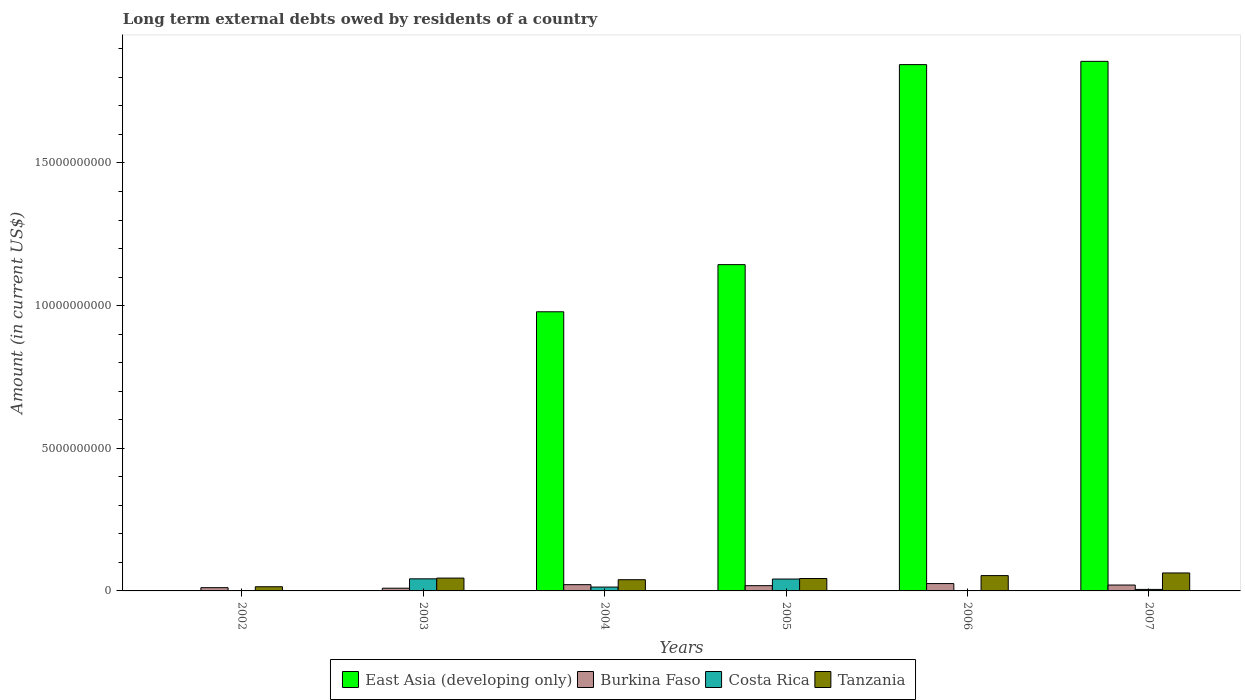How many different coloured bars are there?
Your response must be concise. 4. Are the number of bars per tick equal to the number of legend labels?
Your response must be concise. No. What is the label of the 2nd group of bars from the left?
Your answer should be compact. 2003. What is the amount of long-term external debts owed by residents in Tanzania in 2003?
Offer a very short reply. 4.50e+08. Across all years, what is the maximum amount of long-term external debts owed by residents in Tanzania?
Ensure brevity in your answer.  6.30e+08. Across all years, what is the minimum amount of long-term external debts owed by residents in East Asia (developing only)?
Your response must be concise. 0. In which year was the amount of long-term external debts owed by residents in Tanzania maximum?
Give a very brief answer. 2007. What is the total amount of long-term external debts owed by residents in East Asia (developing only) in the graph?
Offer a terse response. 5.82e+1. What is the difference between the amount of long-term external debts owed by residents in East Asia (developing only) in 2004 and that in 2007?
Provide a succinct answer. -8.78e+09. What is the difference between the amount of long-term external debts owed by residents in Burkina Faso in 2007 and the amount of long-term external debts owed by residents in Costa Rica in 2004?
Your answer should be compact. 7.13e+07. What is the average amount of long-term external debts owed by residents in East Asia (developing only) per year?
Give a very brief answer. 9.71e+09. In the year 2004, what is the difference between the amount of long-term external debts owed by residents in Tanzania and amount of long-term external debts owed by residents in Burkina Faso?
Give a very brief answer. 1.74e+08. What is the ratio of the amount of long-term external debts owed by residents in East Asia (developing only) in 2005 to that in 2007?
Your answer should be very brief. 0.62. Is the amount of long-term external debts owed by residents in Tanzania in 2003 less than that in 2006?
Provide a short and direct response. Yes. What is the difference between the highest and the second highest amount of long-term external debts owed by residents in Burkina Faso?
Give a very brief answer. 3.86e+07. What is the difference between the highest and the lowest amount of long-term external debts owed by residents in Burkina Faso?
Give a very brief answer. 1.62e+08. Is the sum of the amount of long-term external debts owed by residents in Burkina Faso in 2002 and 2004 greater than the maximum amount of long-term external debts owed by residents in Costa Rica across all years?
Provide a succinct answer. No. How many years are there in the graph?
Provide a short and direct response. 6. What is the difference between two consecutive major ticks on the Y-axis?
Your answer should be very brief. 5.00e+09. Are the values on the major ticks of Y-axis written in scientific E-notation?
Ensure brevity in your answer.  No. Does the graph contain any zero values?
Provide a short and direct response. Yes. What is the title of the graph?
Your response must be concise. Long term external debts owed by residents of a country. Does "Peru" appear as one of the legend labels in the graph?
Provide a succinct answer. No. What is the Amount (in current US$) of East Asia (developing only) in 2002?
Your answer should be very brief. 0. What is the Amount (in current US$) of Burkina Faso in 2002?
Give a very brief answer. 1.14e+08. What is the Amount (in current US$) in Costa Rica in 2002?
Provide a short and direct response. 0. What is the Amount (in current US$) of Tanzania in 2002?
Make the answer very short. 1.46e+08. What is the Amount (in current US$) in Burkina Faso in 2003?
Give a very brief answer. 9.52e+07. What is the Amount (in current US$) in Costa Rica in 2003?
Your answer should be compact. 4.24e+08. What is the Amount (in current US$) in Tanzania in 2003?
Offer a very short reply. 4.50e+08. What is the Amount (in current US$) of East Asia (developing only) in 2004?
Your response must be concise. 9.78e+09. What is the Amount (in current US$) of Burkina Faso in 2004?
Make the answer very short. 2.19e+08. What is the Amount (in current US$) in Costa Rica in 2004?
Your answer should be compact. 1.35e+08. What is the Amount (in current US$) in Tanzania in 2004?
Make the answer very short. 3.93e+08. What is the Amount (in current US$) in East Asia (developing only) in 2005?
Provide a short and direct response. 1.14e+1. What is the Amount (in current US$) of Burkina Faso in 2005?
Keep it short and to the point. 1.84e+08. What is the Amount (in current US$) in Costa Rica in 2005?
Give a very brief answer. 4.17e+08. What is the Amount (in current US$) of Tanzania in 2005?
Your answer should be compact. 4.35e+08. What is the Amount (in current US$) in East Asia (developing only) in 2006?
Keep it short and to the point. 1.84e+1. What is the Amount (in current US$) in Burkina Faso in 2006?
Make the answer very short. 2.58e+08. What is the Amount (in current US$) in Tanzania in 2006?
Make the answer very short. 5.37e+08. What is the Amount (in current US$) in East Asia (developing only) in 2007?
Ensure brevity in your answer.  1.86e+1. What is the Amount (in current US$) in Burkina Faso in 2007?
Keep it short and to the point. 2.06e+08. What is the Amount (in current US$) of Costa Rica in 2007?
Make the answer very short. 5.27e+07. What is the Amount (in current US$) in Tanzania in 2007?
Your answer should be compact. 6.30e+08. Across all years, what is the maximum Amount (in current US$) in East Asia (developing only)?
Your answer should be very brief. 1.86e+1. Across all years, what is the maximum Amount (in current US$) in Burkina Faso?
Ensure brevity in your answer.  2.58e+08. Across all years, what is the maximum Amount (in current US$) in Costa Rica?
Your answer should be very brief. 4.24e+08. Across all years, what is the maximum Amount (in current US$) in Tanzania?
Make the answer very short. 6.30e+08. Across all years, what is the minimum Amount (in current US$) in East Asia (developing only)?
Provide a short and direct response. 0. Across all years, what is the minimum Amount (in current US$) in Burkina Faso?
Keep it short and to the point. 9.52e+07. Across all years, what is the minimum Amount (in current US$) of Costa Rica?
Give a very brief answer. 0. Across all years, what is the minimum Amount (in current US$) in Tanzania?
Offer a very short reply. 1.46e+08. What is the total Amount (in current US$) of East Asia (developing only) in the graph?
Your response must be concise. 5.82e+1. What is the total Amount (in current US$) in Burkina Faso in the graph?
Your answer should be very brief. 1.08e+09. What is the total Amount (in current US$) of Costa Rica in the graph?
Your response must be concise. 1.03e+09. What is the total Amount (in current US$) in Tanzania in the graph?
Offer a terse response. 2.59e+09. What is the difference between the Amount (in current US$) in Burkina Faso in 2002 and that in 2003?
Your answer should be very brief. 1.88e+07. What is the difference between the Amount (in current US$) of Tanzania in 2002 and that in 2003?
Your answer should be very brief. -3.04e+08. What is the difference between the Amount (in current US$) in Burkina Faso in 2002 and that in 2004?
Your answer should be compact. -1.05e+08. What is the difference between the Amount (in current US$) in Tanzania in 2002 and that in 2004?
Your answer should be very brief. -2.47e+08. What is the difference between the Amount (in current US$) in Burkina Faso in 2002 and that in 2005?
Provide a succinct answer. -7.01e+07. What is the difference between the Amount (in current US$) in Tanzania in 2002 and that in 2005?
Provide a succinct answer. -2.89e+08. What is the difference between the Amount (in current US$) of Burkina Faso in 2002 and that in 2006?
Provide a short and direct response. -1.44e+08. What is the difference between the Amount (in current US$) in Tanzania in 2002 and that in 2006?
Make the answer very short. -3.91e+08. What is the difference between the Amount (in current US$) of Burkina Faso in 2002 and that in 2007?
Offer a terse response. -9.21e+07. What is the difference between the Amount (in current US$) of Tanzania in 2002 and that in 2007?
Provide a short and direct response. -4.83e+08. What is the difference between the Amount (in current US$) in Burkina Faso in 2003 and that in 2004?
Give a very brief answer. -1.24e+08. What is the difference between the Amount (in current US$) in Costa Rica in 2003 and that in 2004?
Your answer should be compact. 2.89e+08. What is the difference between the Amount (in current US$) of Tanzania in 2003 and that in 2004?
Give a very brief answer. 5.70e+07. What is the difference between the Amount (in current US$) in Burkina Faso in 2003 and that in 2005?
Offer a terse response. -8.88e+07. What is the difference between the Amount (in current US$) in Costa Rica in 2003 and that in 2005?
Offer a very short reply. 6.95e+06. What is the difference between the Amount (in current US$) in Tanzania in 2003 and that in 2005?
Your response must be concise. 1.50e+07. What is the difference between the Amount (in current US$) of Burkina Faso in 2003 and that in 2006?
Your response must be concise. -1.62e+08. What is the difference between the Amount (in current US$) in Tanzania in 2003 and that in 2006?
Keep it short and to the point. -8.70e+07. What is the difference between the Amount (in current US$) in Burkina Faso in 2003 and that in 2007?
Provide a short and direct response. -1.11e+08. What is the difference between the Amount (in current US$) in Costa Rica in 2003 and that in 2007?
Offer a very short reply. 3.71e+08. What is the difference between the Amount (in current US$) in Tanzania in 2003 and that in 2007?
Your answer should be compact. -1.80e+08. What is the difference between the Amount (in current US$) in East Asia (developing only) in 2004 and that in 2005?
Give a very brief answer. -1.65e+09. What is the difference between the Amount (in current US$) of Burkina Faso in 2004 and that in 2005?
Your response must be concise. 3.51e+07. What is the difference between the Amount (in current US$) in Costa Rica in 2004 and that in 2005?
Your answer should be compact. -2.82e+08. What is the difference between the Amount (in current US$) of Tanzania in 2004 and that in 2005?
Your response must be concise. -4.20e+07. What is the difference between the Amount (in current US$) in East Asia (developing only) in 2004 and that in 2006?
Ensure brevity in your answer.  -8.66e+09. What is the difference between the Amount (in current US$) in Burkina Faso in 2004 and that in 2006?
Offer a terse response. -3.86e+07. What is the difference between the Amount (in current US$) of Tanzania in 2004 and that in 2006?
Keep it short and to the point. -1.44e+08. What is the difference between the Amount (in current US$) of East Asia (developing only) in 2004 and that in 2007?
Keep it short and to the point. -8.78e+09. What is the difference between the Amount (in current US$) in Burkina Faso in 2004 and that in 2007?
Your answer should be compact. 1.30e+07. What is the difference between the Amount (in current US$) of Costa Rica in 2004 and that in 2007?
Offer a terse response. 8.21e+07. What is the difference between the Amount (in current US$) of Tanzania in 2004 and that in 2007?
Keep it short and to the point. -2.37e+08. What is the difference between the Amount (in current US$) in East Asia (developing only) in 2005 and that in 2006?
Give a very brief answer. -7.01e+09. What is the difference between the Amount (in current US$) of Burkina Faso in 2005 and that in 2006?
Your answer should be compact. -7.37e+07. What is the difference between the Amount (in current US$) in Tanzania in 2005 and that in 2006?
Make the answer very short. -1.02e+08. What is the difference between the Amount (in current US$) of East Asia (developing only) in 2005 and that in 2007?
Offer a very short reply. -7.13e+09. What is the difference between the Amount (in current US$) of Burkina Faso in 2005 and that in 2007?
Make the answer very short. -2.21e+07. What is the difference between the Amount (in current US$) in Costa Rica in 2005 and that in 2007?
Keep it short and to the point. 3.64e+08. What is the difference between the Amount (in current US$) of Tanzania in 2005 and that in 2007?
Give a very brief answer. -1.95e+08. What is the difference between the Amount (in current US$) in East Asia (developing only) in 2006 and that in 2007?
Keep it short and to the point. -1.14e+08. What is the difference between the Amount (in current US$) in Burkina Faso in 2006 and that in 2007?
Provide a succinct answer. 5.16e+07. What is the difference between the Amount (in current US$) in Tanzania in 2006 and that in 2007?
Your response must be concise. -9.25e+07. What is the difference between the Amount (in current US$) of Burkina Faso in 2002 and the Amount (in current US$) of Costa Rica in 2003?
Offer a very short reply. -3.10e+08. What is the difference between the Amount (in current US$) of Burkina Faso in 2002 and the Amount (in current US$) of Tanzania in 2003?
Your answer should be very brief. -3.36e+08. What is the difference between the Amount (in current US$) of Burkina Faso in 2002 and the Amount (in current US$) of Costa Rica in 2004?
Make the answer very short. -2.08e+07. What is the difference between the Amount (in current US$) in Burkina Faso in 2002 and the Amount (in current US$) in Tanzania in 2004?
Offer a very short reply. -2.79e+08. What is the difference between the Amount (in current US$) of Burkina Faso in 2002 and the Amount (in current US$) of Costa Rica in 2005?
Give a very brief answer. -3.03e+08. What is the difference between the Amount (in current US$) of Burkina Faso in 2002 and the Amount (in current US$) of Tanzania in 2005?
Your response must be concise. -3.21e+08. What is the difference between the Amount (in current US$) of Burkina Faso in 2002 and the Amount (in current US$) of Tanzania in 2006?
Your answer should be compact. -4.23e+08. What is the difference between the Amount (in current US$) in Burkina Faso in 2002 and the Amount (in current US$) in Costa Rica in 2007?
Ensure brevity in your answer.  6.12e+07. What is the difference between the Amount (in current US$) of Burkina Faso in 2002 and the Amount (in current US$) of Tanzania in 2007?
Provide a succinct answer. -5.16e+08. What is the difference between the Amount (in current US$) of Burkina Faso in 2003 and the Amount (in current US$) of Costa Rica in 2004?
Your answer should be very brief. -3.96e+07. What is the difference between the Amount (in current US$) in Burkina Faso in 2003 and the Amount (in current US$) in Tanzania in 2004?
Provide a short and direct response. -2.98e+08. What is the difference between the Amount (in current US$) in Costa Rica in 2003 and the Amount (in current US$) in Tanzania in 2004?
Give a very brief answer. 3.05e+07. What is the difference between the Amount (in current US$) of Burkina Faso in 2003 and the Amount (in current US$) of Costa Rica in 2005?
Your answer should be very brief. -3.21e+08. What is the difference between the Amount (in current US$) of Burkina Faso in 2003 and the Amount (in current US$) of Tanzania in 2005?
Provide a succinct answer. -3.40e+08. What is the difference between the Amount (in current US$) of Costa Rica in 2003 and the Amount (in current US$) of Tanzania in 2005?
Keep it short and to the point. -1.15e+07. What is the difference between the Amount (in current US$) in Burkina Faso in 2003 and the Amount (in current US$) in Tanzania in 2006?
Ensure brevity in your answer.  -4.42e+08. What is the difference between the Amount (in current US$) in Costa Rica in 2003 and the Amount (in current US$) in Tanzania in 2006?
Offer a very short reply. -1.14e+08. What is the difference between the Amount (in current US$) of Burkina Faso in 2003 and the Amount (in current US$) of Costa Rica in 2007?
Give a very brief answer. 4.24e+07. What is the difference between the Amount (in current US$) in Burkina Faso in 2003 and the Amount (in current US$) in Tanzania in 2007?
Keep it short and to the point. -5.34e+08. What is the difference between the Amount (in current US$) of Costa Rica in 2003 and the Amount (in current US$) of Tanzania in 2007?
Provide a short and direct response. -2.06e+08. What is the difference between the Amount (in current US$) of East Asia (developing only) in 2004 and the Amount (in current US$) of Burkina Faso in 2005?
Your answer should be very brief. 9.60e+09. What is the difference between the Amount (in current US$) of East Asia (developing only) in 2004 and the Amount (in current US$) of Costa Rica in 2005?
Your answer should be very brief. 9.37e+09. What is the difference between the Amount (in current US$) of East Asia (developing only) in 2004 and the Amount (in current US$) of Tanzania in 2005?
Ensure brevity in your answer.  9.35e+09. What is the difference between the Amount (in current US$) in Burkina Faso in 2004 and the Amount (in current US$) in Costa Rica in 2005?
Offer a terse response. -1.98e+08. What is the difference between the Amount (in current US$) in Burkina Faso in 2004 and the Amount (in current US$) in Tanzania in 2005?
Provide a succinct answer. -2.16e+08. What is the difference between the Amount (in current US$) of Costa Rica in 2004 and the Amount (in current US$) of Tanzania in 2005?
Keep it short and to the point. -3.00e+08. What is the difference between the Amount (in current US$) of East Asia (developing only) in 2004 and the Amount (in current US$) of Burkina Faso in 2006?
Keep it short and to the point. 9.53e+09. What is the difference between the Amount (in current US$) of East Asia (developing only) in 2004 and the Amount (in current US$) of Tanzania in 2006?
Provide a short and direct response. 9.25e+09. What is the difference between the Amount (in current US$) of Burkina Faso in 2004 and the Amount (in current US$) of Tanzania in 2006?
Ensure brevity in your answer.  -3.18e+08. What is the difference between the Amount (in current US$) in Costa Rica in 2004 and the Amount (in current US$) in Tanzania in 2006?
Your response must be concise. -4.02e+08. What is the difference between the Amount (in current US$) of East Asia (developing only) in 2004 and the Amount (in current US$) of Burkina Faso in 2007?
Give a very brief answer. 9.58e+09. What is the difference between the Amount (in current US$) of East Asia (developing only) in 2004 and the Amount (in current US$) of Costa Rica in 2007?
Offer a terse response. 9.73e+09. What is the difference between the Amount (in current US$) of East Asia (developing only) in 2004 and the Amount (in current US$) of Tanzania in 2007?
Give a very brief answer. 9.15e+09. What is the difference between the Amount (in current US$) of Burkina Faso in 2004 and the Amount (in current US$) of Costa Rica in 2007?
Your answer should be compact. 1.66e+08. What is the difference between the Amount (in current US$) in Burkina Faso in 2004 and the Amount (in current US$) in Tanzania in 2007?
Provide a short and direct response. -4.11e+08. What is the difference between the Amount (in current US$) of Costa Rica in 2004 and the Amount (in current US$) of Tanzania in 2007?
Offer a terse response. -4.95e+08. What is the difference between the Amount (in current US$) of East Asia (developing only) in 2005 and the Amount (in current US$) of Burkina Faso in 2006?
Offer a terse response. 1.12e+1. What is the difference between the Amount (in current US$) in East Asia (developing only) in 2005 and the Amount (in current US$) in Tanzania in 2006?
Your answer should be compact. 1.09e+1. What is the difference between the Amount (in current US$) in Burkina Faso in 2005 and the Amount (in current US$) in Tanzania in 2006?
Ensure brevity in your answer.  -3.53e+08. What is the difference between the Amount (in current US$) in Costa Rica in 2005 and the Amount (in current US$) in Tanzania in 2006?
Your answer should be compact. -1.20e+08. What is the difference between the Amount (in current US$) of East Asia (developing only) in 2005 and the Amount (in current US$) of Burkina Faso in 2007?
Provide a short and direct response. 1.12e+1. What is the difference between the Amount (in current US$) of East Asia (developing only) in 2005 and the Amount (in current US$) of Costa Rica in 2007?
Your answer should be compact. 1.14e+1. What is the difference between the Amount (in current US$) of East Asia (developing only) in 2005 and the Amount (in current US$) of Tanzania in 2007?
Your response must be concise. 1.08e+1. What is the difference between the Amount (in current US$) of Burkina Faso in 2005 and the Amount (in current US$) of Costa Rica in 2007?
Give a very brief answer. 1.31e+08. What is the difference between the Amount (in current US$) in Burkina Faso in 2005 and the Amount (in current US$) in Tanzania in 2007?
Give a very brief answer. -4.46e+08. What is the difference between the Amount (in current US$) in Costa Rica in 2005 and the Amount (in current US$) in Tanzania in 2007?
Provide a short and direct response. -2.13e+08. What is the difference between the Amount (in current US$) of East Asia (developing only) in 2006 and the Amount (in current US$) of Burkina Faso in 2007?
Keep it short and to the point. 1.82e+1. What is the difference between the Amount (in current US$) in East Asia (developing only) in 2006 and the Amount (in current US$) in Costa Rica in 2007?
Provide a short and direct response. 1.84e+1. What is the difference between the Amount (in current US$) of East Asia (developing only) in 2006 and the Amount (in current US$) of Tanzania in 2007?
Ensure brevity in your answer.  1.78e+1. What is the difference between the Amount (in current US$) in Burkina Faso in 2006 and the Amount (in current US$) in Costa Rica in 2007?
Your response must be concise. 2.05e+08. What is the difference between the Amount (in current US$) in Burkina Faso in 2006 and the Amount (in current US$) in Tanzania in 2007?
Your response must be concise. -3.72e+08. What is the average Amount (in current US$) of East Asia (developing only) per year?
Your answer should be compact. 9.71e+09. What is the average Amount (in current US$) in Burkina Faso per year?
Offer a terse response. 1.79e+08. What is the average Amount (in current US$) of Costa Rica per year?
Provide a short and direct response. 1.71e+08. What is the average Amount (in current US$) of Tanzania per year?
Provide a succinct answer. 4.32e+08. In the year 2002, what is the difference between the Amount (in current US$) of Burkina Faso and Amount (in current US$) of Tanzania?
Offer a very short reply. -3.23e+07. In the year 2003, what is the difference between the Amount (in current US$) in Burkina Faso and Amount (in current US$) in Costa Rica?
Your answer should be compact. -3.28e+08. In the year 2003, what is the difference between the Amount (in current US$) of Burkina Faso and Amount (in current US$) of Tanzania?
Ensure brevity in your answer.  -3.55e+08. In the year 2003, what is the difference between the Amount (in current US$) of Costa Rica and Amount (in current US$) of Tanzania?
Ensure brevity in your answer.  -2.65e+07. In the year 2004, what is the difference between the Amount (in current US$) of East Asia (developing only) and Amount (in current US$) of Burkina Faso?
Provide a short and direct response. 9.57e+09. In the year 2004, what is the difference between the Amount (in current US$) of East Asia (developing only) and Amount (in current US$) of Costa Rica?
Your response must be concise. 9.65e+09. In the year 2004, what is the difference between the Amount (in current US$) of East Asia (developing only) and Amount (in current US$) of Tanzania?
Your response must be concise. 9.39e+09. In the year 2004, what is the difference between the Amount (in current US$) in Burkina Faso and Amount (in current US$) in Costa Rica?
Your response must be concise. 8.43e+07. In the year 2004, what is the difference between the Amount (in current US$) of Burkina Faso and Amount (in current US$) of Tanzania?
Keep it short and to the point. -1.74e+08. In the year 2004, what is the difference between the Amount (in current US$) of Costa Rica and Amount (in current US$) of Tanzania?
Offer a terse response. -2.58e+08. In the year 2005, what is the difference between the Amount (in current US$) of East Asia (developing only) and Amount (in current US$) of Burkina Faso?
Your response must be concise. 1.13e+1. In the year 2005, what is the difference between the Amount (in current US$) in East Asia (developing only) and Amount (in current US$) in Costa Rica?
Your answer should be very brief. 1.10e+1. In the year 2005, what is the difference between the Amount (in current US$) in East Asia (developing only) and Amount (in current US$) in Tanzania?
Give a very brief answer. 1.10e+1. In the year 2005, what is the difference between the Amount (in current US$) in Burkina Faso and Amount (in current US$) in Costa Rica?
Ensure brevity in your answer.  -2.33e+08. In the year 2005, what is the difference between the Amount (in current US$) in Burkina Faso and Amount (in current US$) in Tanzania?
Your answer should be very brief. -2.51e+08. In the year 2005, what is the difference between the Amount (in current US$) of Costa Rica and Amount (in current US$) of Tanzania?
Ensure brevity in your answer.  -1.84e+07. In the year 2006, what is the difference between the Amount (in current US$) of East Asia (developing only) and Amount (in current US$) of Burkina Faso?
Keep it short and to the point. 1.82e+1. In the year 2006, what is the difference between the Amount (in current US$) in East Asia (developing only) and Amount (in current US$) in Tanzania?
Your response must be concise. 1.79e+1. In the year 2006, what is the difference between the Amount (in current US$) in Burkina Faso and Amount (in current US$) in Tanzania?
Your response must be concise. -2.79e+08. In the year 2007, what is the difference between the Amount (in current US$) in East Asia (developing only) and Amount (in current US$) in Burkina Faso?
Your response must be concise. 1.84e+1. In the year 2007, what is the difference between the Amount (in current US$) in East Asia (developing only) and Amount (in current US$) in Costa Rica?
Provide a short and direct response. 1.85e+1. In the year 2007, what is the difference between the Amount (in current US$) of East Asia (developing only) and Amount (in current US$) of Tanzania?
Your answer should be very brief. 1.79e+1. In the year 2007, what is the difference between the Amount (in current US$) of Burkina Faso and Amount (in current US$) of Costa Rica?
Offer a terse response. 1.53e+08. In the year 2007, what is the difference between the Amount (in current US$) in Burkina Faso and Amount (in current US$) in Tanzania?
Provide a short and direct response. -4.24e+08. In the year 2007, what is the difference between the Amount (in current US$) in Costa Rica and Amount (in current US$) in Tanzania?
Make the answer very short. -5.77e+08. What is the ratio of the Amount (in current US$) in Burkina Faso in 2002 to that in 2003?
Give a very brief answer. 1.2. What is the ratio of the Amount (in current US$) of Tanzania in 2002 to that in 2003?
Provide a succinct answer. 0.33. What is the ratio of the Amount (in current US$) in Burkina Faso in 2002 to that in 2004?
Your answer should be very brief. 0.52. What is the ratio of the Amount (in current US$) of Tanzania in 2002 to that in 2004?
Keep it short and to the point. 0.37. What is the ratio of the Amount (in current US$) of Burkina Faso in 2002 to that in 2005?
Your answer should be compact. 0.62. What is the ratio of the Amount (in current US$) in Tanzania in 2002 to that in 2005?
Your answer should be compact. 0.34. What is the ratio of the Amount (in current US$) in Burkina Faso in 2002 to that in 2006?
Offer a terse response. 0.44. What is the ratio of the Amount (in current US$) in Tanzania in 2002 to that in 2006?
Offer a very short reply. 0.27. What is the ratio of the Amount (in current US$) in Burkina Faso in 2002 to that in 2007?
Keep it short and to the point. 0.55. What is the ratio of the Amount (in current US$) of Tanzania in 2002 to that in 2007?
Offer a terse response. 0.23. What is the ratio of the Amount (in current US$) of Burkina Faso in 2003 to that in 2004?
Provide a short and direct response. 0.43. What is the ratio of the Amount (in current US$) of Costa Rica in 2003 to that in 2004?
Make the answer very short. 3.14. What is the ratio of the Amount (in current US$) in Tanzania in 2003 to that in 2004?
Offer a terse response. 1.15. What is the ratio of the Amount (in current US$) in Burkina Faso in 2003 to that in 2005?
Make the answer very short. 0.52. What is the ratio of the Amount (in current US$) in Costa Rica in 2003 to that in 2005?
Your answer should be compact. 1.02. What is the ratio of the Amount (in current US$) of Tanzania in 2003 to that in 2005?
Offer a very short reply. 1.03. What is the ratio of the Amount (in current US$) of Burkina Faso in 2003 to that in 2006?
Make the answer very short. 0.37. What is the ratio of the Amount (in current US$) in Tanzania in 2003 to that in 2006?
Your response must be concise. 0.84. What is the ratio of the Amount (in current US$) in Burkina Faso in 2003 to that in 2007?
Provide a short and direct response. 0.46. What is the ratio of the Amount (in current US$) of Costa Rica in 2003 to that in 2007?
Your answer should be compact. 8.03. What is the ratio of the Amount (in current US$) in Tanzania in 2003 to that in 2007?
Provide a succinct answer. 0.71. What is the ratio of the Amount (in current US$) in East Asia (developing only) in 2004 to that in 2005?
Give a very brief answer. 0.86. What is the ratio of the Amount (in current US$) of Burkina Faso in 2004 to that in 2005?
Provide a short and direct response. 1.19. What is the ratio of the Amount (in current US$) in Costa Rica in 2004 to that in 2005?
Offer a very short reply. 0.32. What is the ratio of the Amount (in current US$) of Tanzania in 2004 to that in 2005?
Offer a terse response. 0.9. What is the ratio of the Amount (in current US$) of East Asia (developing only) in 2004 to that in 2006?
Your answer should be very brief. 0.53. What is the ratio of the Amount (in current US$) in Burkina Faso in 2004 to that in 2006?
Your answer should be compact. 0.85. What is the ratio of the Amount (in current US$) in Tanzania in 2004 to that in 2006?
Ensure brevity in your answer.  0.73. What is the ratio of the Amount (in current US$) in East Asia (developing only) in 2004 to that in 2007?
Your response must be concise. 0.53. What is the ratio of the Amount (in current US$) of Burkina Faso in 2004 to that in 2007?
Ensure brevity in your answer.  1.06. What is the ratio of the Amount (in current US$) in Costa Rica in 2004 to that in 2007?
Offer a very short reply. 2.56. What is the ratio of the Amount (in current US$) of Tanzania in 2004 to that in 2007?
Your answer should be very brief. 0.62. What is the ratio of the Amount (in current US$) of East Asia (developing only) in 2005 to that in 2006?
Your answer should be compact. 0.62. What is the ratio of the Amount (in current US$) in Burkina Faso in 2005 to that in 2006?
Keep it short and to the point. 0.71. What is the ratio of the Amount (in current US$) of Tanzania in 2005 to that in 2006?
Your response must be concise. 0.81. What is the ratio of the Amount (in current US$) of East Asia (developing only) in 2005 to that in 2007?
Make the answer very short. 0.62. What is the ratio of the Amount (in current US$) of Burkina Faso in 2005 to that in 2007?
Provide a succinct answer. 0.89. What is the ratio of the Amount (in current US$) in Costa Rica in 2005 to that in 2007?
Give a very brief answer. 7.9. What is the ratio of the Amount (in current US$) in Tanzania in 2005 to that in 2007?
Keep it short and to the point. 0.69. What is the ratio of the Amount (in current US$) in Burkina Faso in 2006 to that in 2007?
Provide a succinct answer. 1.25. What is the ratio of the Amount (in current US$) of Tanzania in 2006 to that in 2007?
Make the answer very short. 0.85. What is the difference between the highest and the second highest Amount (in current US$) in East Asia (developing only)?
Give a very brief answer. 1.14e+08. What is the difference between the highest and the second highest Amount (in current US$) of Burkina Faso?
Your answer should be very brief. 3.86e+07. What is the difference between the highest and the second highest Amount (in current US$) in Costa Rica?
Offer a very short reply. 6.95e+06. What is the difference between the highest and the second highest Amount (in current US$) of Tanzania?
Keep it short and to the point. 9.25e+07. What is the difference between the highest and the lowest Amount (in current US$) in East Asia (developing only)?
Provide a succinct answer. 1.86e+1. What is the difference between the highest and the lowest Amount (in current US$) in Burkina Faso?
Give a very brief answer. 1.62e+08. What is the difference between the highest and the lowest Amount (in current US$) of Costa Rica?
Your answer should be compact. 4.24e+08. What is the difference between the highest and the lowest Amount (in current US$) in Tanzania?
Provide a succinct answer. 4.83e+08. 